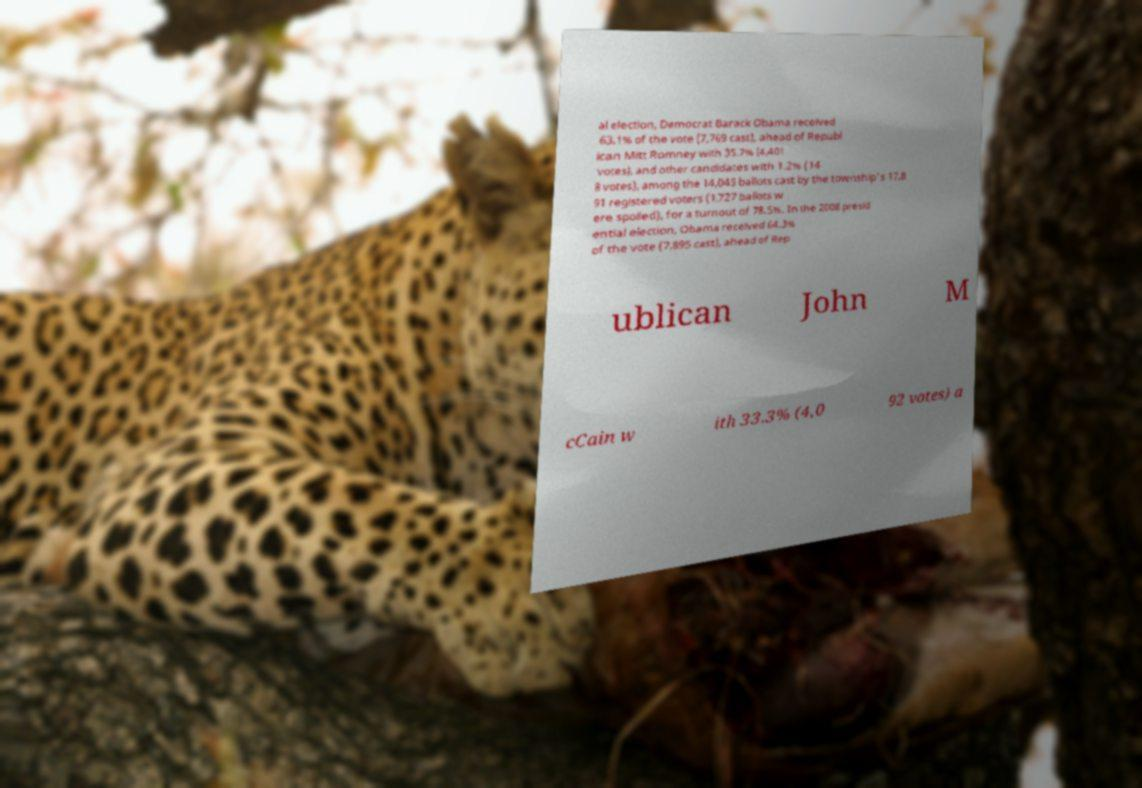Please identify and transcribe the text found in this image. al election, Democrat Barack Obama received 63.1% of the vote (7,769 cast), ahead of Republ ican Mitt Romney with 35.7% (4,401 votes), and other candidates with 1.2% (14 8 votes), among the 14,045 ballots cast by the township's 17,8 91 registered voters (1,727 ballots w ere spoiled), for a turnout of 78.5%. In the 2008 presid ential election, Obama received 64.3% of the vote (7,895 cast), ahead of Rep ublican John M cCain w ith 33.3% (4,0 92 votes) a 